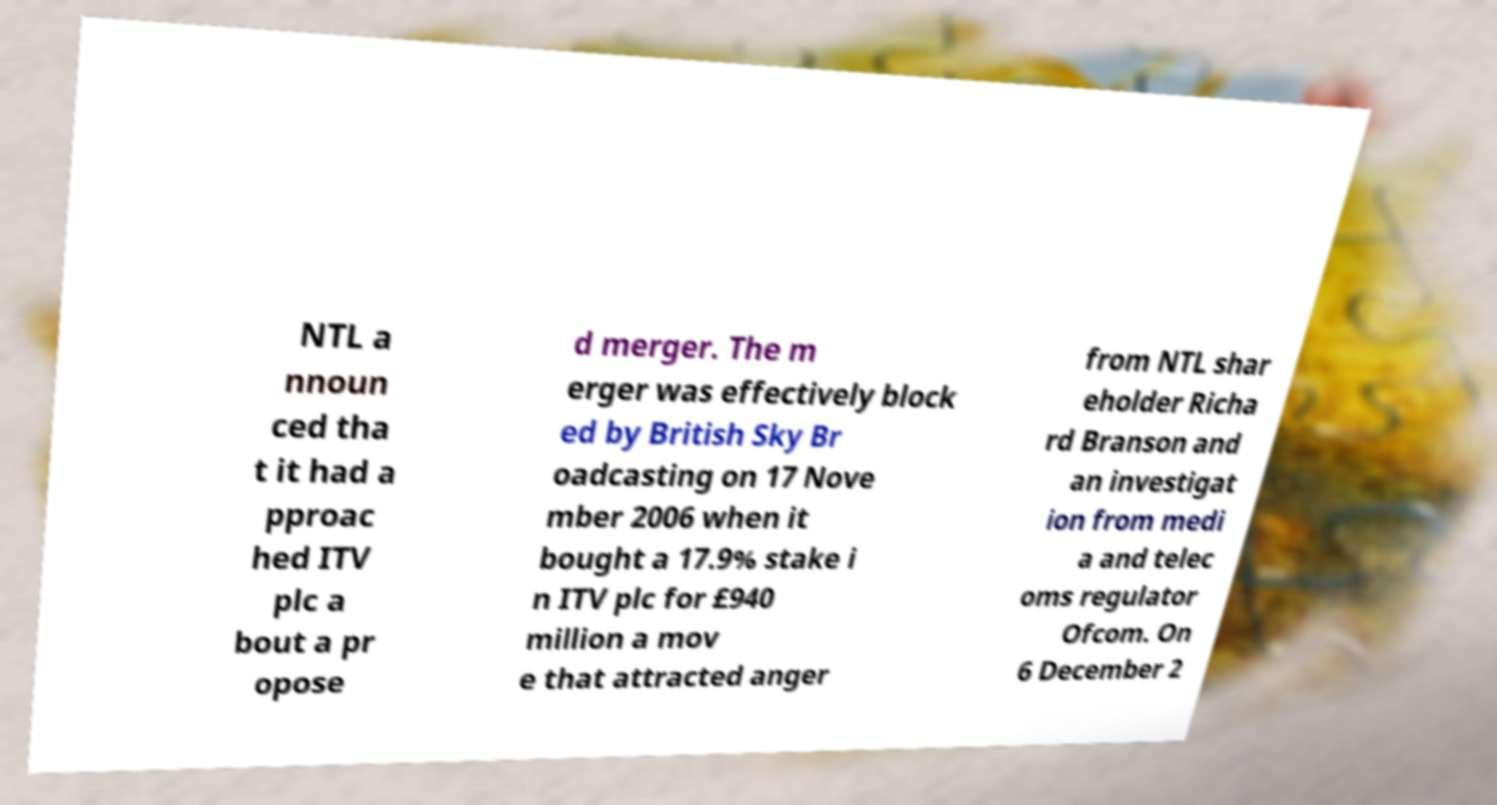Please identify and transcribe the text found in this image. NTL a nnoun ced tha t it had a pproac hed ITV plc a bout a pr opose d merger. The m erger was effectively block ed by British Sky Br oadcasting on 17 Nove mber 2006 when it bought a 17.9% stake i n ITV plc for £940 million a mov e that attracted anger from NTL shar eholder Richa rd Branson and an investigat ion from medi a and telec oms regulator Ofcom. On 6 December 2 